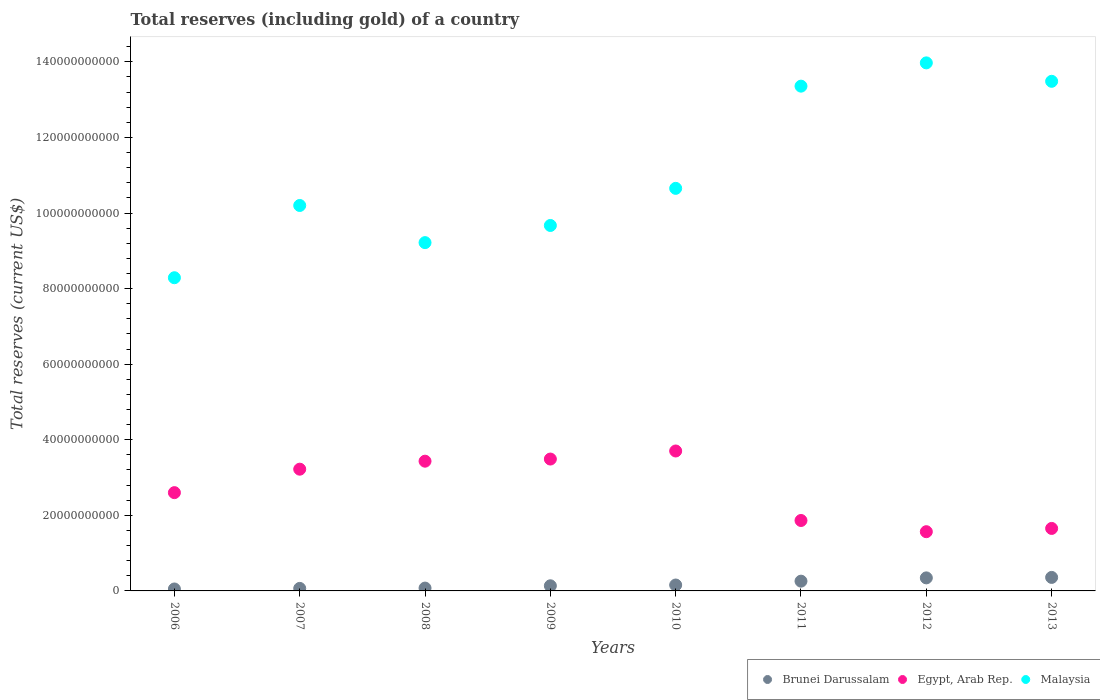What is the total reserves (including gold) in Egypt, Arab Rep. in 2008?
Ensure brevity in your answer.  3.43e+1. Across all years, what is the maximum total reserves (including gold) in Egypt, Arab Rep.?
Your answer should be compact. 3.70e+1. Across all years, what is the minimum total reserves (including gold) in Brunei Darussalam?
Your answer should be compact. 5.14e+08. In which year was the total reserves (including gold) in Brunei Darussalam maximum?
Ensure brevity in your answer.  2013. In which year was the total reserves (including gold) in Brunei Darussalam minimum?
Give a very brief answer. 2006. What is the total total reserves (including gold) in Egypt, Arab Rep. in the graph?
Provide a succinct answer. 2.15e+11. What is the difference between the total reserves (including gold) in Brunei Darussalam in 2011 and that in 2012?
Give a very brief answer. -8.65e+08. What is the difference between the total reserves (including gold) in Malaysia in 2013 and the total reserves (including gold) in Egypt, Arab Rep. in 2008?
Provide a succinct answer. 1.01e+11. What is the average total reserves (including gold) in Egypt, Arab Rep. per year?
Offer a terse response. 2.69e+1. In the year 2007, what is the difference between the total reserves (including gold) in Brunei Darussalam and total reserves (including gold) in Malaysia?
Ensure brevity in your answer.  -1.01e+11. What is the ratio of the total reserves (including gold) in Brunei Darussalam in 2010 to that in 2011?
Offer a terse response. 0.61. Is the total reserves (including gold) in Malaysia in 2008 less than that in 2013?
Offer a very short reply. Yes. Is the difference between the total reserves (including gold) in Brunei Darussalam in 2009 and 2013 greater than the difference between the total reserves (including gold) in Malaysia in 2009 and 2013?
Your answer should be very brief. Yes. What is the difference between the highest and the second highest total reserves (including gold) in Brunei Darussalam?
Make the answer very short. 1.26e+08. What is the difference between the highest and the lowest total reserves (including gold) in Brunei Darussalam?
Your answer should be compact. 3.06e+09. In how many years, is the total reserves (including gold) in Egypt, Arab Rep. greater than the average total reserves (including gold) in Egypt, Arab Rep. taken over all years?
Your answer should be compact. 4. Is the sum of the total reserves (including gold) in Brunei Darussalam in 2008 and 2009 greater than the maximum total reserves (including gold) in Egypt, Arab Rep. across all years?
Give a very brief answer. No. Is it the case that in every year, the sum of the total reserves (including gold) in Brunei Darussalam and total reserves (including gold) in Malaysia  is greater than the total reserves (including gold) in Egypt, Arab Rep.?
Keep it short and to the point. Yes. Does the total reserves (including gold) in Egypt, Arab Rep. monotonically increase over the years?
Your response must be concise. No. Is the total reserves (including gold) in Egypt, Arab Rep. strictly greater than the total reserves (including gold) in Brunei Darussalam over the years?
Provide a succinct answer. Yes. Is the total reserves (including gold) in Malaysia strictly less than the total reserves (including gold) in Brunei Darussalam over the years?
Your response must be concise. No. What is the difference between two consecutive major ticks on the Y-axis?
Provide a succinct answer. 2.00e+1. Are the values on the major ticks of Y-axis written in scientific E-notation?
Make the answer very short. No. Does the graph contain grids?
Make the answer very short. No. How are the legend labels stacked?
Ensure brevity in your answer.  Horizontal. What is the title of the graph?
Keep it short and to the point. Total reserves (including gold) of a country. What is the label or title of the Y-axis?
Provide a succinct answer. Total reserves (current US$). What is the Total reserves (current US$) of Brunei Darussalam in 2006?
Offer a terse response. 5.14e+08. What is the Total reserves (current US$) in Egypt, Arab Rep. in 2006?
Offer a terse response. 2.60e+1. What is the Total reserves (current US$) in Malaysia in 2006?
Ensure brevity in your answer.  8.29e+1. What is the Total reserves (current US$) in Brunei Darussalam in 2007?
Provide a succinct answer. 6.67e+08. What is the Total reserves (current US$) in Egypt, Arab Rep. in 2007?
Your answer should be compact. 3.22e+1. What is the Total reserves (current US$) in Malaysia in 2007?
Provide a short and direct response. 1.02e+11. What is the Total reserves (current US$) in Brunei Darussalam in 2008?
Provide a succinct answer. 7.51e+08. What is the Total reserves (current US$) in Egypt, Arab Rep. in 2008?
Keep it short and to the point. 3.43e+1. What is the Total reserves (current US$) in Malaysia in 2008?
Your answer should be compact. 9.22e+1. What is the Total reserves (current US$) of Brunei Darussalam in 2009?
Your answer should be compact. 1.36e+09. What is the Total reserves (current US$) in Egypt, Arab Rep. in 2009?
Your answer should be very brief. 3.49e+1. What is the Total reserves (current US$) in Malaysia in 2009?
Make the answer very short. 9.67e+1. What is the Total reserves (current US$) in Brunei Darussalam in 2010?
Provide a short and direct response. 1.56e+09. What is the Total reserves (current US$) of Egypt, Arab Rep. in 2010?
Provide a short and direct response. 3.70e+1. What is the Total reserves (current US$) in Malaysia in 2010?
Offer a very short reply. 1.07e+11. What is the Total reserves (current US$) in Brunei Darussalam in 2011?
Offer a terse response. 2.58e+09. What is the Total reserves (current US$) of Egypt, Arab Rep. in 2011?
Provide a short and direct response. 1.86e+1. What is the Total reserves (current US$) in Malaysia in 2011?
Provide a succinct answer. 1.34e+11. What is the Total reserves (current US$) of Brunei Darussalam in 2012?
Offer a terse response. 3.45e+09. What is the Total reserves (current US$) of Egypt, Arab Rep. in 2012?
Offer a very short reply. 1.57e+1. What is the Total reserves (current US$) in Malaysia in 2012?
Your response must be concise. 1.40e+11. What is the Total reserves (current US$) of Brunei Darussalam in 2013?
Provide a short and direct response. 3.58e+09. What is the Total reserves (current US$) in Egypt, Arab Rep. in 2013?
Make the answer very short. 1.65e+1. What is the Total reserves (current US$) of Malaysia in 2013?
Provide a succinct answer. 1.35e+11. Across all years, what is the maximum Total reserves (current US$) in Brunei Darussalam?
Your response must be concise. 3.58e+09. Across all years, what is the maximum Total reserves (current US$) in Egypt, Arab Rep.?
Your answer should be very brief. 3.70e+1. Across all years, what is the maximum Total reserves (current US$) in Malaysia?
Provide a succinct answer. 1.40e+11. Across all years, what is the minimum Total reserves (current US$) in Brunei Darussalam?
Your response must be concise. 5.14e+08. Across all years, what is the minimum Total reserves (current US$) of Egypt, Arab Rep.?
Make the answer very short. 1.57e+1. Across all years, what is the minimum Total reserves (current US$) of Malaysia?
Provide a succinct answer. 8.29e+1. What is the total Total reserves (current US$) in Brunei Darussalam in the graph?
Provide a succinct answer. 1.45e+1. What is the total Total reserves (current US$) of Egypt, Arab Rep. in the graph?
Keep it short and to the point. 2.15e+11. What is the total Total reserves (current US$) of Malaysia in the graph?
Your answer should be compact. 8.88e+11. What is the difference between the Total reserves (current US$) of Brunei Darussalam in 2006 and that in 2007?
Provide a short and direct response. -1.54e+08. What is the difference between the Total reserves (current US$) of Egypt, Arab Rep. in 2006 and that in 2007?
Make the answer very short. -6.21e+09. What is the difference between the Total reserves (current US$) in Malaysia in 2006 and that in 2007?
Make the answer very short. -1.91e+1. What is the difference between the Total reserves (current US$) in Brunei Darussalam in 2006 and that in 2008?
Provide a succinct answer. -2.38e+08. What is the difference between the Total reserves (current US$) in Egypt, Arab Rep. in 2006 and that in 2008?
Your answer should be very brief. -8.32e+09. What is the difference between the Total reserves (current US$) of Malaysia in 2006 and that in 2008?
Make the answer very short. -9.29e+09. What is the difference between the Total reserves (current US$) in Brunei Darussalam in 2006 and that in 2009?
Keep it short and to the point. -8.44e+08. What is the difference between the Total reserves (current US$) in Egypt, Arab Rep. in 2006 and that in 2009?
Provide a succinct answer. -8.89e+09. What is the difference between the Total reserves (current US$) in Malaysia in 2006 and that in 2009?
Provide a succinct answer. -1.38e+1. What is the difference between the Total reserves (current US$) in Brunei Darussalam in 2006 and that in 2010?
Your answer should be compact. -1.05e+09. What is the difference between the Total reserves (current US$) in Egypt, Arab Rep. in 2006 and that in 2010?
Provide a short and direct response. -1.10e+1. What is the difference between the Total reserves (current US$) in Malaysia in 2006 and that in 2010?
Your answer should be compact. -2.37e+1. What is the difference between the Total reserves (current US$) in Brunei Darussalam in 2006 and that in 2011?
Offer a terse response. -2.07e+09. What is the difference between the Total reserves (current US$) of Egypt, Arab Rep. in 2006 and that in 2011?
Ensure brevity in your answer.  7.37e+09. What is the difference between the Total reserves (current US$) in Malaysia in 2006 and that in 2011?
Offer a terse response. -5.07e+1. What is the difference between the Total reserves (current US$) of Brunei Darussalam in 2006 and that in 2012?
Provide a short and direct response. -2.94e+09. What is the difference between the Total reserves (current US$) of Egypt, Arab Rep. in 2006 and that in 2012?
Your answer should be very brief. 1.03e+1. What is the difference between the Total reserves (current US$) of Malaysia in 2006 and that in 2012?
Your response must be concise. -5.69e+1. What is the difference between the Total reserves (current US$) in Brunei Darussalam in 2006 and that in 2013?
Provide a succinct answer. -3.06e+09. What is the difference between the Total reserves (current US$) of Egypt, Arab Rep. in 2006 and that in 2013?
Your answer should be very brief. 9.47e+09. What is the difference between the Total reserves (current US$) of Malaysia in 2006 and that in 2013?
Your response must be concise. -5.20e+1. What is the difference between the Total reserves (current US$) of Brunei Darussalam in 2007 and that in 2008?
Your response must be concise. -8.37e+07. What is the difference between the Total reserves (current US$) in Egypt, Arab Rep. in 2007 and that in 2008?
Your answer should be compact. -2.12e+09. What is the difference between the Total reserves (current US$) in Malaysia in 2007 and that in 2008?
Provide a succinct answer. 9.83e+09. What is the difference between the Total reserves (current US$) in Brunei Darussalam in 2007 and that in 2009?
Ensure brevity in your answer.  -6.90e+08. What is the difference between the Total reserves (current US$) of Egypt, Arab Rep. in 2007 and that in 2009?
Offer a very short reply. -2.68e+09. What is the difference between the Total reserves (current US$) of Malaysia in 2007 and that in 2009?
Keep it short and to the point. 5.29e+09. What is the difference between the Total reserves (current US$) of Brunei Darussalam in 2007 and that in 2010?
Give a very brief answer. -8.96e+08. What is the difference between the Total reserves (current US$) in Egypt, Arab Rep. in 2007 and that in 2010?
Make the answer very short. -4.81e+09. What is the difference between the Total reserves (current US$) in Malaysia in 2007 and that in 2010?
Give a very brief answer. -4.53e+09. What is the difference between the Total reserves (current US$) in Brunei Darussalam in 2007 and that in 2011?
Your response must be concise. -1.92e+09. What is the difference between the Total reserves (current US$) in Egypt, Arab Rep. in 2007 and that in 2011?
Provide a short and direct response. 1.36e+1. What is the difference between the Total reserves (current US$) of Malaysia in 2007 and that in 2011?
Your answer should be compact. -3.16e+1. What is the difference between the Total reserves (current US$) of Brunei Darussalam in 2007 and that in 2012?
Offer a very short reply. -2.78e+09. What is the difference between the Total reserves (current US$) of Egypt, Arab Rep. in 2007 and that in 2012?
Your answer should be very brief. 1.65e+1. What is the difference between the Total reserves (current US$) in Malaysia in 2007 and that in 2012?
Ensure brevity in your answer.  -3.77e+1. What is the difference between the Total reserves (current US$) of Brunei Darussalam in 2007 and that in 2013?
Give a very brief answer. -2.91e+09. What is the difference between the Total reserves (current US$) of Egypt, Arab Rep. in 2007 and that in 2013?
Keep it short and to the point. 1.57e+1. What is the difference between the Total reserves (current US$) of Malaysia in 2007 and that in 2013?
Your answer should be compact. -3.29e+1. What is the difference between the Total reserves (current US$) of Brunei Darussalam in 2008 and that in 2009?
Ensure brevity in your answer.  -6.06e+08. What is the difference between the Total reserves (current US$) in Egypt, Arab Rep. in 2008 and that in 2009?
Provide a short and direct response. -5.66e+08. What is the difference between the Total reserves (current US$) in Malaysia in 2008 and that in 2009?
Provide a succinct answer. -4.54e+09. What is the difference between the Total reserves (current US$) of Brunei Darussalam in 2008 and that in 2010?
Keep it short and to the point. -8.12e+08. What is the difference between the Total reserves (current US$) in Egypt, Arab Rep. in 2008 and that in 2010?
Keep it short and to the point. -2.70e+09. What is the difference between the Total reserves (current US$) in Malaysia in 2008 and that in 2010?
Keep it short and to the point. -1.44e+1. What is the difference between the Total reserves (current US$) of Brunei Darussalam in 2008 and that in 2011?
Ensure brevity in your answer.  -1.83e+09. What is the difference between the Total reserves (current US$) in Egypt, Arab Rep. in 2008 and that in 2011?
Give a very brief answer. 1.57e+1. What is the difference between the Total reserves (current US$) of Malaysia in 2008 and that in 2011?
Your answer should be very brief. -4.14e+1. What is the difference between the Total reserves (current US$) of Brunei Darussalam in 2008 and that in 2012?
Offer a terse response. -2.70e+09. What is the difference between the Total reserves (current US$) in Egypt, Arab Rep. in 2008 and that in 2012?
Provide a short and direct response. 1.87e+1. What is the difference between the Total reserves (current US$) in Malaysia in 2008 and that in 2012?
Keep it short and to the point. -4.76e+1. What is the difference between the Total reserves (current US$) of Brunei Darussalam in 2008 and that in 2013?
Your response must be concise. -2.82e+09. What is the difference between the Total reserves (current US$) of Egypt, Arab Rep. in 2008 and that in 2013?
Provide a short and direct response. 1.78e+1. What is the difference between the Total reserves (current US$) in Malaysia in 2008 and that in 2013?
Keep it short and to the point. -4.27e+1. What is the difference between the Total reserves (current US$) of Brunei Darussalam in 2009 and that in 2010?
Your response must be concise. -2.06e+08. What is the difference between the Total reserves (current US$) in Egypt, Arab Rep. in 2009 and that in 2010?
Provide a short and direct response. -2.13e+09. What is the difference between the Total reserves (current US$) in Malaysia in 2009 and that in 2010?
Offer a terse response. -9.82e+09. What is the difference between the Total reserves (current US$) in Brunei Darussalam in 2009 and that in 2011?
Make the answer very short. -1.23e+09. What is the difference between the Total reserves (current US$) of Egypt, Arab Rep. in 2009 and that in 2011?
Your answer should be very brief. 1.63e+1. What is the difference between the Total reserves (current US$) in Malaysia in 2009 and that in 2011?
Your answer should be compact. -3.69e+1. What is the difference between the Total reserves (current US$) of Brunei Darussalam in 2009 and that in 2012?
Provide a short and direct response. -2.09e+09. What is the difference between the Total reserves (current US$) of Egypt, Arab Rep. in 2009 and that in 2012?
Provide a succinct answer. 1.92e+1. What is the difference between the Total reserves (current US$) of Malaysia in 2009 and that in 2012?
Provide a succinct answer. -4.30e+1. What is the difference between the Total reserves (current US$) of Brunei Darussalam in 2009 and that in 2013?
Make the answer very short. -2.22e+09. What is the difference between the Total reserves (current US$) of Egypt, Arab Rep. in 2009 and that in 2013?
Your answer should be compact. 1.84e+1. What is the difference between the Total reserves (current US$) in Malaysia in 2009 and that in 2013?
Provide a succinct answer. -3.81e+1. What is the difference between the Total reserves (current US$) of Brunei Darussalam in 2010 and that in 2011?
Offer a very short reply. -1.02e+09. What is the difference between the Total reserves (current US$) of Egypt, Arab Rep. in 2010 and that in 2011?
Give a very brief answer. 1.84e+1. What is the difference between the Total reserves (current US$) of Malaysia in 2010 and that in 2011?
Give a very brief answer. -2.70e+1. What is the difference between the Total reserves (current US$) in Brunei Darussalam in 2010 and that in 2012?
Keep it short and to the point. -1.89e+09. What is the difference between the Total reserves (current US$) in Egypt, Arab Rep. in 2010 and that in 2012?
Make the answer very short. 2.14e+1. What is the difference between the Total reserves (current US$) in Malaysia in 2010 and that in 2012?
Keep it short and to the point. -3.32e+1. What is the difference between the Total reserves (current US$) in Brunei Darussalam in 2010 and that in 2013?
Keep it short and to the point. -2.01e+09. What is the difference between the Total reserves (current US$) in Egypt, Arab Rep. in 2010 and that in 2013?
Provide a succinct answer. 2.05e+1. What is the difference between the Total reserves (current US$) of Malaysia in 2010 and that in 2013?
Provide a succinct answer. -2.83e+1. What is the difference between the Total reserves (current US$) in Brunei Darussalam in 2011 and that in 2012?
Keep it short and to the point. -8.65e+08. What is the difference between the Total reserves (current US$) in Egypt, Arab Rep. in 2011 and that in 2012?
Your response must be concise. 2.97e+09. What is the difference between the Total reserves (current US$) of Malaysia in 2011 and that in 2012?
Provide a succinct answer. -6.16e+09. What is the difference between the Total reserves (current US$) of Brunei Darussalam in 2011 and that in 2013?
Your answer should be compact. -9.92e+08. What is the difference between the Total reserves (current US$) of Egypt, Arab Rep. in 2011 and that in 2013?
Your answer should be very brief. 2.10e+09. What is the difference between the Total reserves (current US$) in Malaysia in 2011 and that in 2013?
Your answer should be very brief. -1.28e+09. What is the difference between the Total reserves (current US$) in Brunei Darussalam in 2012 and that in 2013?
Your response must be concise. -1.26e+08. What is the difference between the Total reserves (current US$) of Egypt, Arab Rep. in 2012 and that in 2013?
Keep it short and to the point. -8.64e+08. What is the difference between the Total reserves (current US$) in Malaysia in 2012 and that in 2013?
Make the answer very short. 4.88e+09. What is the difference between the Total reserves (current US$) in Brunei Darussalam in 2006 and the Total reserves (current US$) in Egypt, Arab Rep. in 2007?
Make the answer very short. -3.17e+1. What is the difference between the Total reserves (current US$) of Brunei Darussalam in 2006 and the Total reserves (current US$) of Malaysia in 2007?
Provide a succinct answer. -1.01e+11. What is the difference between the Total reserves (current US$) in Egypt, Arab Rep. in 2006 and the Total reserves (current US$) in Malaysia in 2007?
Your response must be concise. -7.60e+1. What is the difference between the Total reserves (current US$) of Brunei Darussalam in 2006 and the Total reserves (current US$) of Egypt, Arab Rep. in 2008?
Your answer should be very brief. -3.38e+1. What is the difference between the Total reserves (current US$) in Brunei Darussalam in 2006 and the Total reserves (current US$) in Malaysia in 2008?
Provide a short and direct response. -9.17e+1. What is the difference between the Total reserves (current US$) of Egypt, Arab Rep. in 2006 and the Total reserves (current US$) of Malaysia in 2008?
Give a very brief answer. -6.62e+1. What is the difference between the Total reserves (current US$) of Brunei Darussalam in 2006 and the Total reserves (current US$) of Egypt, Arab Rep. in 2009?
Keep it short and to the point. -3.44e+1. What is the difference between the Total reserves (current US$) in Brunei Darussalam in 2006 and the Total reserves (current US$) in Malaysia in 2009?
Your response must be concise. -9.62e+1. What is the difference between the Total reserves (current US$) of Egypt, Arab Rep. in 2006 and the Total reserves (current US$) of Malaysia in 2009?
Make the answer very short. -7.07e+1. What is the difference between the Total reserves (current US$) in Brunei Darussalam in 2006 and the Total reserves (current US$) in Egypt, Arab Rep. in 2010?
Provide a succinct answer. -3.65e+1. What is the difference between the Total reserves (current US$) in Brunei Darussalam in 2006 and the Total reserves (current US$) in Malaysia in 2010?
Keep it short and to the point. -1.06e+11. What is the difference between the Total reserves (current US$) in Egypt, Arab Rep. in 2006 and the Total reserves (current US$) in Malaysia in 2010?
Offer a very short reply. -8.05e+1. What is the difference between the Total reserves (current US$) in Brunei Darussalam in 2006 and the Total reserves (current US$) in Egypt, Arab Rep. in 2011?
Make the answer very short. -1.81e+1. What is the difference between the Total reserves (current US$) in Brunei Darussalam in 2006 and the Total reserves (current US$) in Malaysia in 2011?
Make the answer very short. -1.33e+11. What is the difference between the Total reserves (current US$) in Egypt, Arab Rep. in 2006 and the Total reserves (current US$) in Malaysia in 2011?
Your response must be concise. -1.08e+11. What is the difference between the Total reserves (current US$) of Brunei Darussalam in 2006 and the Total reserves (current US$) of Egypt, Arab Rep. in 2012?
Ensure brevity in your answer.  -1.52e+1. What is the difference between the Total reserves (current US$) in Brunei Darussalam in 2006 and the Total reserves (current US$) in Malaysia in 2012?
Your response must be concise. -1.39e+11. What is the difference between the Total reserves (current US$) of Egypt, Arab Rep. in 2006 and the Total reserves (current US$) of Malaysia in 2012?
Make the answer very short. -1.14e+11. What is the difference between the Total reserves (current US$) in Brunei Darussalam in 2006 and the Total reserves (current US$) in Egypt, Arab Rep. in 2013?
Give a very brief answer. -1.60e+1. What is the difference between the Total reserves (current US$) in Brunei Darussalam in 2006 and the Total reserves (current US$) in Malaysia in 2013?
Offer a terse response. -1.34e+11. What is the difference between the Total reserves (current US$) in Egypt, Arab Rep. in 2006 and the Total reserves (current US$) in Malaysia in 2013?
Offer a terse response. -1.09e+11. What is the difference between the Total reserves (current US$) of Brunei Darussalam in 2007 and the Total reserves (current US$) of Egypt, Arab Rep. in 2008?
Your answer should be compact. -3.37e+1. What is the difference between the Total reserves (current US$) of Brunei Darussalam in 2007 and the Total reserves (current US$) of Malaysia in 2008?
Make the answer very short. -9.15e+1. What is the difference between the Total reserves (current US$) of Egypt, Arab Rep. in 2007 and the Total reserves (current US$) of Malaysia in 2008?
Your answer should be compact. -6.00e+1. What is the difference between the Total reserves (current US$) of Brunei Darussalam in 2007 and the Total reserves (current US$) of Egypt, Arab Rep. in 2009?
Provide a succinct answer. -3.42e+1. What is the difference between the Total reserves (current US$) of Brunei Darussalam in 2007 and the Total reserves (current US$) of Malaysia in 2009?
Keep it short and to the point. -9.60e+1. What is the difference between the Total reserves (current US$) in Egypt, Arab Rep. in 2007 and the Total reserves (current US$) in Malaysia in 2009?
Your answer should be compact. -6.45e+1. What is the difference between the Total reserves (current US$) of Brunei Darussalam in 2007 and the Total reserves (current US$) of Egypt, Arab Rep. in 2010?
Keep it short and to the point. -3.64e+1. What is the difference between the Total reserves (current US$) of Brunei Darussalam in 2007 and the Total reserves (current US$) of Malaysia in 2010?
Your response must be concise. -1.06e+11. What is the difference between the Total reserves (current US$) of Egypt, Arab Rep. in 2007 and the Total reserves (current US$) of Malaysia in 2010?
Offer a terse response. -7.43e+1. What is the difference between the Total reserves (current US$) in Brunei Darussalam in 2007 and the Total reserves (current US$) in Egypt, Arab Rep. in 2011?
Your response must be concise. -1.80e+1. What is the difference between the Total reserves (current US$) of Brunei Darussalam in 2007 and the Total reserves (current US$) of Malaysia in 2011?
Your response must be concise. -1.33e+11. What is the difference between the Total reserves (current US$) of Egypt, Arab Rep. in 2007 and the Total reserves (current US$) of Malaysia in 2011?
Keep it short and to the point. -1.01e+11. What is the difference between the Total reserves (current US$) of Brunei Darussalam in 2007 and the Total reserves (current US$) of Egypt, Arab Rep. in 2012?
Offer a very short reply. -1.50e+1. What is the difference between the Total reserves (current US$) of Brunei Darussalam in 2007 and the Total reserves (current US$) of Malaysia in 2012?
Provide a short and direct response. -1.39e+11. What is the difference between the Total reserves (current US$) in Egypt, Arab Rep. in 2007 and the Total reserves (current US$) in Malaysia in 2012?
Provide a succinct answer. -1.08e+11. What is the difference between the Total reserves (current US$) of Brunei Darussalam in 2007 and the Total reserves (current US$) of Egypt, Arab Rep. in 2013?
Give a very brief answer. -1.59e+1. What is the difference between the Total reserves (current US$) in Brunei Darussalam in 2007 and the Total reserves (current US$) in Malaysia in 2013?
Provide a succinct answer. -1.34e+11. What is the difference between the Total reserves (current US$) of Egypt, Arab Rep. in 2007 and the Total reserves (current US$) of Malaysia in 2013?
Provide a short and direct response. -1.03e+11. What is the difference between the Total reserves (current US$) of Brunei Darussalam in 2008 and the Total reserves (current US$) of Egypt, Arab Rep. in 2009?
Provide a succinct answer. -3.41e+1. What is the difference between the Total reserves (current US$) in Brunei Darussalam in 2008 and the Total reserves (current US$) in Malaysia in 2009?
Give a very brief answer. -9.60e+1. What is the difference between the Total reserves (current US$) in Egypt, Arab Rep. in 2008 and the Total reserves (current US$) in Malaysia in 2009?
Your answer should be compact. -6.24e+1. What is the difference between the Total reserves (current US$) in Brunei Darussalam in 2008 and the Total reserves (current US$) in Egypt, Arab Rep. in 2010?
Offer a very short reply. -3.63e+1. What is the difference between the Total reserves (current US$) in Brunei Darussalam in 2008 and the Total reserves (current US$) in Malaysia in 2010?
Your answer should be compact. -1.06e+11. What is the difference between the Total reserves (current US$) in Egypt, Arab Rep. in 2008 and the Total reserves (current US$) in Malaysia in 2010?
Provide a short and direct response. -7.22e+1. What is the difference between the Total reserves (current US$) of Brunei Darussalam in 2008 and the Total reserves (current US$) of Egypt, Arab Rep. in 2011?
Your response must be concise. -1.79e+1. What is the difference between the Total reserves (current US$) in Brunei Darussalam in 2008 and the Total reserves (current US$) in Malaysia in 2011?
Offer a very short reply. -1.33e+11. What is the difference between the Total reserves (current US$) in Egypt, Arab Rep. in 2008 and the Total reserves (current US$) in Malaysia in 2011?
Offer a very short reply. -9.92e+1. What is the difference between the Total reserves (current US$) in Brunei Darussalam in 2008 and the Total reserves (current US$) in Egypt, Arab Rep. in 2012?
Keep it short and to the point. -1.49e+1. What is the difference between the Total reserves (current US$) of Brunei Darussalam in 2008 and the Total reserves (current US$) of Malaysia in 2012?
Your response must be concise. -1.39e+11. What is the difference between the Total reserves (current US$) in Egypt, Arab Rep. in 2008 and the Total reserves (current US$) in Malaysia in 2012?
Your answer should be compact. -1.05e+11. What is the difference between the Total reserves (current US$) in Brunei Darussalam in 2008 and the Total reserves (current US$) in Egypt, Arab Rep. in 2013?
Provide a succinct answer. -1.58e+1. What is the difference between the Total reserves (current US$) in Brunei Darussalam in 2008 and the Total reserves (current US$) in Malaysia in 2013?
Give a very brief answer. -1.34e+11. What is the difference between the Total reserves (current US$) of Egypt, Arab Rep. in 2008 and the Total reserves (current US$) of Malaysia in 2013?
Provide a succinct answer. -1.01e+11. What is the difference between the Total reserves (current US$) in Brunei Darussalam in 2009 and the Total reserves (current US$) in Egypt, Arab Rep. in 2010?
Your answer should be compact. -3.57e+1. What is the difference between the Total reserves (current US$) of Brunei Darussalam in 2009 and the Total reserves (current US$) of Malaysia in 2010?
Provide a succinct answer. -1.05e+11. What is the difference between the Total reserves (current US$) of Egypt, Arab Rep. in 2009 and the Total reserves (current US$) of Malaysia in 2010?
Your answer should be compact. -7.16e+1. What is the difference between the Total reserves (current US$) in Brunei Darussalam in 2009 and the Total reserves (current US$) in Egypt, Arab Rep. in 2011?
Your response must be concise. -1.73e+1. What is the difference between the Total reserves (current US$) in Brunei Darussalam in 2009 and the Total reserves (current US$) in Malaysia in 2011?
Your response must be concise. -1.32e+11. What is the difference between the Total reserves (current US$) of Egypt, Arab Rep. in 2009 and the Total reserves (current US$) of Malaysia in 2011?
Make the answer very short. -9.87e+1. What is the difference between the Total reserves (current US$) in Brunei Darussalam in 2009 and the Total reserves (current US$) in Egypt, Arab Rep. in 2012?
Provide a short and direct response. -1.43e+1. What is the difference between the Total reserves (current US$) of Brunei Darussalam in 2009 and the Total reserves (current US$) of Malaysia in 2012?
Provide a short and direct response. -1.38e+11. What is the difference between the Total reserves (current US$) of Egypt, Arab Rep. in 2009 and the Total reserves (current US$) of Malaysia in 2012?
Your answer should be very brief. -1.05e+11. What is the difference between the Total reserves (current US$) in Brunei Darussalam in 2009 and the Total reserves (current US$) in Egypt, Arab Rep. in 2013?
Provide a short and direct response. -1.52e+1. What is the difference between the Total reserves (current US$) of Brunei Darussalam in 2009 and the Total reserves (current US$) of Malaysia in 2013?
Make the answer very short. -1.33e+11. What is the difference between the Total reserves (current US$) in Egypt, Arab Rep. in 2009 and the Total reserves (current US$) in Malaysia in 2013?
Your answer should be compact. -1.00e+11. What is the difference between the Total reserves (current US$) in Brunei Darussalam in 2010 and the Total reserves (current US$) in Egypt, Arab Rep. in 2011?
Provide a short and direct response. -1.71e+1. What is the difference between the Total reserves (current US$) in Brunei Darussalam in 2010 and the Total reserves (current US$) in Malaysia in 2011?
Give a very brief answer. -1.32e+11. What is the difference between the Total reserves (current US$) of Egypt, Arab Rep. in 2010 and the Total reserves (current US$) of Malaysia in 2011?
Provide a short and direct response. -9.65e+1. What is the difference between the Total reserves (current US$) of Brunei Darussalam in 2010 and the Total reserves (current US$) of Egypt, Arab Rep. in 2012?
Your answer should be compact. -1.41e+1. What is the difference between the Total reserves (current US$) of Brunei Darussalam in 2010 and the Total reserves (current US$) of Malaysia in 2012?
Give a very brief answer. -1.38e+11. What is the difference between the Total reserves (current US$) of Egypt, Arab Rep. in 2010 and the Total reserves (current US$) of Malaysia in 2012?
Offer a terse response. -1.03e+11. What is the difference between the Total reserves (current US$) in Brunei Darussalam in 2010 and the Total reserves (current US$) in Egypt, Arab Rep. in 2013?
Offer a very short reply. -1.50e+1. What is the difference between the Total reserves (current US$) of Brunei Darussalam in 2010 and the Total reserves (current US$) of Malaysia in 2013?
Your answer should be very brief. -1.33e+11. What is the difference between the Total reserves (current US$) in Egypt, Arab Rep. in 2010 and the Total reserves (current US$) in Malaysia in 2013?
Give a very brief answer. -9.78e+1. What is the difference between the Total reserves (current US$) in Brunei Darussalam in 2011 and the Total reserves (current US$) in Egypt, Arab Rep. in 2012?
Offer a terse response. -1.31e+1. What is the difference between the Total reserves (current US$) in Brunei Darussalam in 2011 and the Total reserves (current US$) in Malaysia in 2012?
Your answer should be compact. -1.37e+11. What is the difference between the Total reserves (current US$) of Egypt, Arab Rep. in 2011 and the Total reserves (current US$) of Malaysia in 2012?
Give a very brief answer. -1.21e+11. What is the difference between the Total reserves (current US$) of Brunei Darussalam in 2011 and the Total reserves (current US$) of Egypt, Arab Rep. in 2013?
Give a very brief answer. -1.40e+1. What is the difference between the Total reserves (current US$) of Brunei Darussalam in 2011 and the Total reserves (current US$) of Malaysia in 2013?
Provide a succinct answer. -1.32e+11. What is the difference between the Total reserves (current US$) in Egypt, Arab Rep. in 2011 and the Total reserves (current US$) in Malaysia in 2013?
Your response must be concise. -1.16e+11. What is the difference between the Total reserves (current US$) of Brunei Darussalam in 2012 and the Total reserves (current US$) of Egypt, Arab Rep. in 2013?
Ensure brevity in your answer.  -1.31e+1. What is the difference between the Total reserves (current US$) in Brunei Darussalam in 2012 and the Total reserves (current US$) in Malaysia in 2013?
Provide a short and direct response. -1.31e+11. What is the difference between the Total reserves (current US$) of Egypt, Arab Rep. in 2012 and the Total reserves (current US$) of Malaysia in 2013?
Your response must be concise. -1.19e+11. What is the average Total reserves (current US$) in Brunei Darussalam per year?
Offer a very short reply. 1.81e+09. What is the average Total reserves (current US$) in Egypt, Arab Rep. per year?
Your answer should be very brief. 2.69e+1. What is the average Total reserves (current US$) of Malaysia per year?
Provide a short and direct response. 1.11e+11. In the year 2006, what is the difference between the Total reserves (current US$) in Brunei Darussalam and Total reserves (current US$) in Egypt, Arab Rep.?
Offer a terse response. -2.55e+1. In the year 2006, what is the difference between the Total reserves (current US$) in Brunei Darussalam and Total reserves (current US$) in Malaysia?
Provide a succinct answer. -8.24e+1. In the year 2006, what is the difference between the Total reserves (current US$) in Egypt, Arab Rep. and Total reserves (current US$) in Malaysia?
Provide a short and direct response. -5.69e+1. In the year 2007, what is the difference between the Total reserves (current US$) in Brunei Darussalam and Total reserves (current US$) in Egypt, Arab Rep.?
Make the answer very short. -3.15e+1. In the year 2007, what is the difference between the Total reserves (current US$) of Brunei Darussalam and Total reserves (current US$) of Malaysia?
Keep it short and to the point. -1.01e+11. In the year 2007, what is the difference between the Total reserves (current US$) in Egypt, Arab Rep. and Total reserves (current US$) in Malaysia?
Keep it short and to the point. -6.98e+1. In the year 2008, what is the difference between the Total reserves (current US$) of Brunei Darussalam and Total reserves (current US$) of Egypt, Arab Rep.?
Ensure brevity in your answer.  -3.36e+1. In the year 2008, what is the difference between the Total reserves (current US$) of Brunei Darussalam and Total reserves (current US$) of Malaysia?
Your response must be concise. -9.14e+1. In the year 2008, what is the difference between the Total reserves (current US$) in Egypt, Arab Rep. and Total reserves (current US$) in Malaysia?
Offer a terse response. -5.78e+1. In the year 2009, what is the difference between the Total reserves (current US$) in Brunei Darussalam and Total reserves (current US$) in Egypt, Arab Rep.?
Provide a succinct answer. -3.35e+1. In the year 2009, what is the difference between the Total reserves (current US$) of Brunei Darussalam and Total reserves (current US$) of Malaysia?
Ensure brevity in your answer.  -9.53e+1. In the year 2009, what is the difference between the Total reserves (current US$) of Egypt, Arab Rep. and Total reserves (current US$) of Malaysia?
Your answer should be compact. -6.18e+1. In the year 2010, what is the difference between the Total reserves (current US$) of Brunei Darussalam and Total reserves (current US$) of Egypt, Arab Rep.?
Make the answer very short. -3.55e+1. In the year 2010, what is the difference between the Total reserves (current US$) of Brunei Darussalam and Total reserves (current US$) of Malaysia?
Offer a terse response. -1.05e+11. In the year 2010, what is the difference between the Total reserves (current US$) of Egypt, Arab Rep. and Total reserves (current US$) of Malaysia?
Give a very brief answer. -6.95e+1. In the year 2011, what is the difference between the Total reserves (current US$) of Brunei Darussalam and Total reserves (current US$) of Egypt, Arab Rep.?
Offer a very short reply. -1.61e+1. In the year 2011, what is the difference between the Total reserves (current US$) in Brunei Darussalam and Total reserves (current US$) in Malaysia?
Ensure brevity in your answer.  -1.31e+11. In the year 2011, what is the difference between the Total reserves (current US$) of Egypt, Arab Rep. and Total reserves (current US$) of Malaysia?
Provide a succinct answer. -1.15e+11. In the year 2012, what is the difference between the Total reserves (current US$) in Brunei Darussalam and Total reserves (current US$) in Egypt, Arab Rep.?
Provide a short and direct response. -1.22e+1. In the year 2012, what is the difference between the Total reserves (current US$) in Brunei Darussalam and Total reserves (current US$) in Malaysia?
Give a very brief answer. -1.36e+11. In the year 2012, what is the difference between the Total reserves (current US$) in Egypt, Arab Rep. and Total reserves (current US$) in Malaysia?
Give a very brief answer. -1.24e+11. In the year 2013, what is the difference between the Total reserves (current US$) of Brunei Darussalam and Total reserves (current US$) of Egypt, Arab Rep.?
Provide a short and direct response. -1.30e+1. In the year 2013, what is the difference between the Total reserves (current US$) of Brunei Darussalam and Total reserves (current US$) of Malaysia?
Provide a short and direct response. -1.31e+11. In the year 2013, what is the difference between the Total reserves (current US$) of Egypt, Arab Rep. and Total reserves (current US$) of Malaysia?
Your answer should be compact. -1.18e+11. What is the ratio of the Total reserves (current US$) in Brunei Darussalam in 2006 to that in 2007?
Provide a short and direct response. 0.77. What is the ratio of the Total reserves (current US$) in Egypt, Arab Rep. in 2006 to that in 2007?
Provide a succinct answer. 0.81. What is the ratio of the Total reserves (current US$) in Malaysia in 2006 to that in 2007?
Your answer should be very brief. 0.81. What is the ratio of the Total reserves (current US$) of Brunei Darussalam in 2006 to that in 2008?
Your answer should be very brief. 0.68. What is the ratio of the Total reserves (current US$) of Egypt, Arab Rep. in 2006 to that in 2008?
Offer a very short reply. 0.76. What is the ratio of the Total reserves (current US$) in Malaysia in 2006 to that in 2008?
Your response must be concise. 0.9. What is the ratio of the Total reserves (current US$) in Brunei Darussalam in 2006 to that in 2009?
Your answer should be very brief. 0.38. What is the ratio of the Total reserves (current US$) in Egypt, Arab Rep. in 2006 to that in 2009?
Ensure brevity in your answer.  0.75. What is the ratio of the Total reserves (current US$) of Malaysia in 2006 to that in 2009?
Your answer should be compact. 0.86. What is the ratio of the Total reserves (current US$) of Brunei Darussalam in 2006 to that in 2010?
Keep it short and to the point. 0.33. What is the ratio of the Total reserves (current US$) of Egypt, Arab Rep. in 2006 to that in 2010?
Provide a succinct answer. 0.7. What is the ratio of the Total reserves (current US$) of Malaysia in 2006 to that in 2010?
Provide a succinct answer. 0.78. What is the ratio of the Total reserves (current US$) in Brunei Darussalam in 2006 to that in 2011?
Offer a very short reply. 0.2. What is the ratio of the Total reserves (current US$) of Egypt, Arab Rep. in 2006 to that in 2011?
Provide a short and direct response. 1.4. What is the ratio of the Total reserves (current US$) in Malaysia in 2006 to that in 2011?
Offer a terse response. 0.62. What is the ratio of the Total reserves (current US$) of Brunei Darussalam in 2006 to that in 2012?
Your answer should be compact. 0.15. What is the ratio of the Total reserves (current US$) of Egypt, Arab Rep. in 2006 to that in 2012?
Keep it short and to the point. 1.66. What is the ratio of the Total reserves (current US$) of Malaysia in 2006 to that in 2012?
Offer a terse response. 0.59. What is the ratio of the Total reserves (current US$) in Brunei Darussalam in 2006 to that in 2013?
Offer a very short reply. 0.14. What is the ratio of the Total reserves (current US$) in Egypt, Arab Rep. in 2006 to that in 2013?
Offer a terse response. 1.57. What is the ratio of the Total reserves (current US$) in Malaysia in 2006 to that in 2013?
Offer a terse response. 0.61. What is the ratio of the Total reserves (current US$) in Brunei Darussalam in 2007 to that in 2008?
Keep it short and to the point. 0.89. What is the ratio of the Total reserves (current US$) of Egypt, Arab Rep. in 2007 to that in 2008?
Your answer should be very brief. 0.94. What is the ratio of the Total reserves (current US$) in Malaysia in 2007 to that in 2008?
Give a very brief answer. 1.11. What is the ratio of the Total reserves (current US$) in Brunei Darussalam in 2007 to that in 2009?
Make the answer very short. 0.49. What is the ratio of the Total reserves (current US$) of Egypt, Arab Rep. in 2007 to that in 2009?
Provide a succinct answer. 0.92. What is the ratio of the Total reserves (current US$) in Malaysia in 2007 to that in 2009?
Make the answer very short. 1.05. What is the ratio of the Total reserves (current US$) in Brunei Darussalam in 2007 to that in 2010?
Offer a very short reply. 0.43. What is the ratio of the Total reserves (current US$) of Egypt, Arab Rep. in 2007 to that in 2010?
Keep it short and to the point. 0.87. What is the ratio of the Total reserves (current US$) of Malaysia in 2007 to that in 2010?
Give a very brief answer. 0.96. What is the ratio of the Total reserves (current US$) of Brunei Darussalam in 2007 to that in 2011?
Your answer should be compact. 0.26. What is the ratio of the Total reserves (current US$) in Egypt, Arab Rep. in 2007 to that in 2011?
Give a very brief answer. 1.73. What is the ratio of the Total reserves (current US$) of Malaysia in 2007 to that in 2011?
Your answer should be very brief. 0.76. What is the ratio of the Total reserves (current US$) in Brunei Darussalam in 2007 to that in 2012?
Give a very brief answer. 0.19. What is the ratio of the Total reserves (current US$) of Egypt, Arab Rep. in 2007 to that in 2012?
Offer a very short reply. 2.06. What is the ratio of the Total reserves (current US$) of Malaysia in 2007 to that in 2012?
Make the answer very short. 0.73. What is the ratio of the Total reserves (current US$) of Brunei Darussalam in 2007 to that in 2013?
Your answer should be very brief. 0.19. What is the ratio of the Total reserves (current US$) in Egypt, Arab Rep. in 2007 to that in 2013?
Your answer should be very brief. 1.95. What is the ratio of the Total reserves (current US$) in Malaysia in 2007 to that in 2013?
Your answer should be compact. 0.76. What is the ratio of the Total reserves (current US$) of Brunei Darussalam in 2008 to that in 2009?
Your answer should be very brief. 0.55. What is the ratio of the Total reserves (current US$) in Egypt, Arab Rep. in 2008 to that in 2009?
Offer a terse response. 0.98. What is the ratio of the Total reserves (current US$) in Malaysia in 2008 to that in 2009?
Give a very brief answer. 0.95. What is the ratio of the Total reserves (current US$) of Brunei Darussalam in 2008 to that in 2010?
Offer a very short reply. 0.48. What is the ratio of the Total reserves (current US$) of Egypt, Arab Rep. in 2008 to that in 2010?
Keep it short and to the point. 0.93. What is the ratio of the Total reserves (current US$) in Malaysia in 2008 to that in 2010?
Provide a short and direct response. 0.87. What is the ratio of the Total reserves (current US$) of Brunei Darussalam in 2008 to that in 2011?
Provide a succinct answer. 0.29. What is the ratio of the Total reserves (current US$) of Egypt, Arab Rep. in 2008 to that in 2011?
Your answer should be very brief. 1.84. What is the ratio of the Total reserves (current US$) in Malaysia in 2008 to that in 2011?
Your answer should be very brief. 0.69. What is the ratio of the Total reserves (current US$) of Brunei Darussalam in 2008 to that in 2012?
Make the answer very short. 0.22. What is the ratio of the Total reserves (current US$) of Egypt, Arab Rep. in 2008 to that in 2012?
Provide a succinct answer. 2.19. What is the ratio of the Total reserves (current US$) of Malaysia in 2008 to that in 2012?
Offer a very short reply. 0.66. What is the ratio of the Total reserves (current US$) in Brunei Darussalam in 2008 to that in 2013?
Make the answer very short. 0.21. What is the ratio of the Total reserves (current US$) in Egypt, Arab Rep. in 2008 to that in 2013?
Give a very brief answer. 2.08. What is the ratio of the Total reserves (current US$) in Malaysia in 2008 to that in 2013?
Offer a terse response. 0.68. What is the ratio of the Total reserves (current US$) of Brunei Darussalam in 2009 to that in 2010?
Your response must be concise. 0.87. What is the ratio of the Total reserves (current US$) of Egypt, Arab Rep. in 2009 to that in 2010?
Provide a short and direct response. 0.94. What is the ratio of the Total reserves (current US$) of Malaysia in 2009 to that in 2010?
Make the answer very short. 0.91. What is the ratio of the Total reserves (current US$) of Brunei Darussalam in 2009 to that in 2011?
Provide a short and direct response. 0.53. What is the ratio of the Total reserves (current US$) of Egypt, Arab Rep. in 2009 to that in 2011?
Offer a terse response. 1.87. What is the ratio of the Total reserves (current US$) in Malaysia in 2009 to that in 2011?
Provide a short and direct response. 0.72. What is the ratio of the Total reserves (current US$) in Brunei Darussalam in 2009 to that in 2012?
Give a very brief answer. 0.39. What is the ratio of the Total reserves (current US$) in Egypt, Arab Rep. in 2009 to that in 2012?
Ensure brevity in your answer.  2.23. What is the ratio of the Total reserves (current US$) in Malaysia in 2009 to that in 2012?
Offer a terse response. 0.69. What is the ratio of the Total reserves (current US$) of Brunei Darussalam in 2009 to that in 2013?
Keep it short and to the point. 0.38. What is the ratio of the Total reserves (current US$) in Egypt, Arab Rep. in 2009 to that in 2013?
Give a very brief answer. 2.11. What is the ratio of the Total reserves (current US$) in Malaysia in 2009 to that in 2013?
Provide a succinct answer. 0.72. What is the ratio of the Total reserves (current US$) in Brunei Darussalam in 2010 to that in 2011?
Ensure brevity in your answer.  0.6. What is the ratio of the Total reserves (current US$) in Egypt, Arab Rep. in 2010 to that in 2011?
Ensure brevity in your answer.  1.99. What is the ratio of the Total reserves (current US$) of Malaysia in 2010 to that in 2011?
Keep it short and to the point. 0.8. What is the ratio of the Total reserves (current US$) in Brunei Darussalam in 2010 to that in 2012?
Keep it short and to the point. 0.45. What is the ratio of the Total reserves (current US$) in Egypt, Arab Rep. in 2010 to that in 2012?
Ensure brevity in your answer.  2.36. What is the ratio of the Total reserves (current US$) in Malaysia in 2010 to that in 2012?
Provide a succinct answer. 0.76. What is the ratio of the Total reserves (current US$) in Brunei Darussalam in 2010 to that in 2013?
Provide a short and direct response. 0.44. What is the ratio of the Total reserves (current US$) of Egypt, Arab Rep. in 2010 to that in 2013?
Give a very brief answer. 2.24. What is the ratio of the Total reserves (current US$) of Malaysia in 2010 to that in 2013?
Provide a succinct answer. 0.79. What is the ratio of the Total reserves (current US$) in Brunei Darussalam in 2011 to that in 2012?
Keep it short and to the point. 0.75. What is the ratio of the Total reserves (current US$) in Egypt, Arab Rep. in 2011 to that in 2012?
Your answer should be very brief. 1.19. What is the ratio of the Total reserves (current US$) in Malaysia in 2011 to that in 2012?
Ensure brevity in your answer.  0.96. What is the ratio of the Total reserves (current US$) of Brunei Darussalam in 2011 to that in 2013?
Your response must be concise. 0.72. What is the ratio of the Total reserves (current US$) of Egypt, Arab Rep. in 2011 to that in 2013?
Make the answer very short. 1.13. What is the ratio of the Total reserves (current US$) in Brunei Darussalam in 2012 to that in 2013?
Ensure brevity in your answer.  0.96. What is the ratio of the Total reserves (current US$) of Egypt, Arab Rep. in 2012 to that in 2013?
Offer a very short reply. 0.95. What is the ratio of the Total reserves (current US$) of Malaysia in 2012 to that in 2013?
Your response must be concise. 1.04. What is the difference between the highest and the second highest Total reserves (current US$) in Brunei Darussalam?
Offer a very short reply. 1.26e+08. What is the difference between the highest and the second highest Total reserves (current US$) of Egypt, Arab Rep.?
Provide a short and direct response. 2.13e+09. What is the difference between the highest and the second highest Total reserves (current US$) of Malaysia?
Offer a terse response. 4.88e+09. What is the difference between the highest and the lowest Total reserves (current US$) in Brunei Darussalam?
Provide a short and direct response. 3.06e+09. What is the difference between the highest and the lowest Total reserves (current US$) in Egypt, Arab Rep.?
Offer a terse response. 2.14e+1. What is the difference between the highest and the lowest Total reserves (current US$) of Malaysia?
Your answer should be compact. 5.69e+1. 